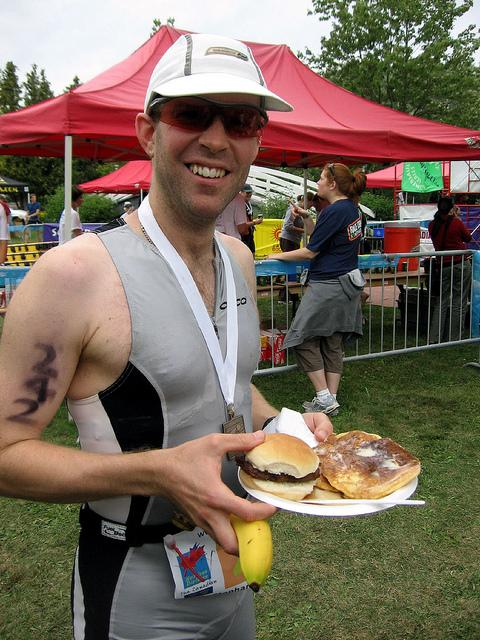Why does the man have numbers written on his arm? Please explain your reasoning. event participant. The man is part of a event. 